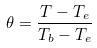Convert formula to latex. <formula><loc_0><loc_0><loc_500><loc_500>\theta = \frac { T - T _ { e } } { T _ { b } - T _ { e } }</formula> 